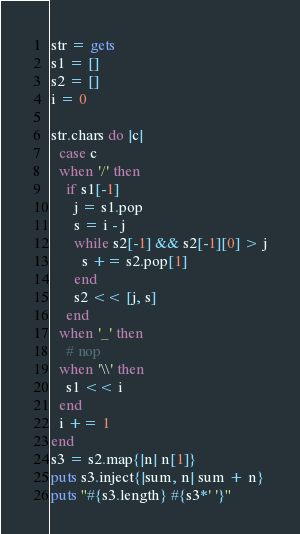<code> <loc_0><loc_0><loc_500><loc_500><_Ruby_>str = gets
s1 = []
s2 = []
i = 0

str.chars do |c|
  case c
  when '/' then
    if s1[-1]
      j = s1.pop
      s = i - j
      while s2[-1] && s2[-1][0] > j
        s += s2.pop[1]
      end
      s2 << [j, s]
    end
  when '_' then
    # nop
  when '\\' then
    s1 << i
  end
  i += 1
end
s3 = s2.map{|n| n[1]}
puts s3.inject{|sum, n| sum + n}
puts "#{s3.length} #{s3*' '}"</code> 